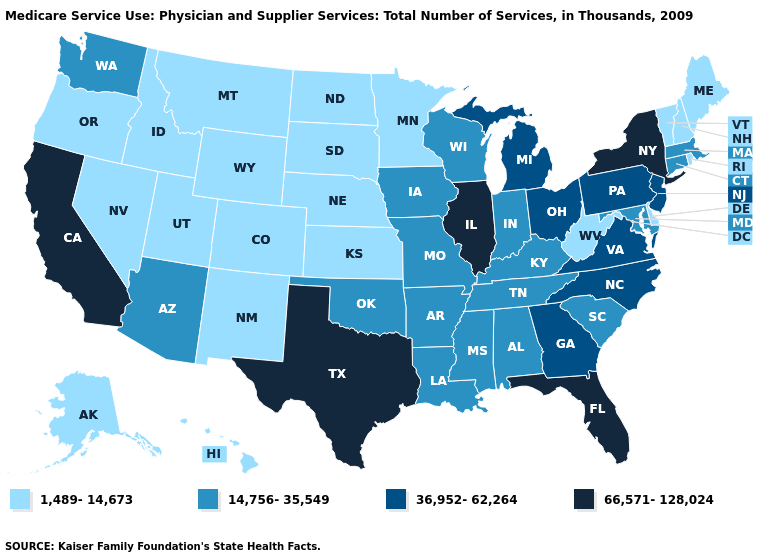Which states have the lowest value in the USA?
Give a very brief answer. Alaska, Colorado, Delaware, Hawaii, Idaho, Kansas, Maine, Minnesota, Montana, Nebraska, Nevada, New Hampshire, New Mexico, North Dakota, Oregon, Rhode Island, South Dakota, Utah, Vermont, West Virginia, Wyoming. What is the value of North Carolina?
Concise answer only. 36,952-62,264. Which states have the lowest value in the USA?
Give a very brief answer. Alaska, Colorado, Delaware, Hawaii, Idaho, Kansas, Maine, Minnesota, Montana, Nebraska, Nevada, New Hampshire, New Mexico, North Dakota, Oregon, Rhode Island, South Dakota, Utah, Vermont, West Virginia, Wyoming. How many symbols are there in the legend?
Be succinct. 4. Name the states that have a value in the range 36,952-62,264?
Keep it brief. Georgia, Michigan, New Jersey, North Carolina, Ohio, Pennsylvania, Virginia. What is the highest value in the USA?
Short answer required. 66,571-128,024. Which states hav the highest value in the MidWest?
Concise answer only. Illinois. Name the states that have a value in the range 66,571-128,024?
Short answer required. California, Florida, Illinois, New York, Texas. Which states have the lowest value in the USA?
Give a very brief answer. Alaska, Colorado, Delaware, Hawaii, Idaho, Kansas, Maine, Minnesota, Montana, Nebraska, Nevada, New Hampshire, New Mexico, North Dakota, Oregon, Rhode Island, South Dakota, Utah, Vermont, West Virginia, Wyoming. Does Kentucky have a lower value than Vermont?
Concise answer only. No. What is the highest value in the USA?
Short answer required. 66,571-128,024. Which states have the lowest value in the Northeast?
Give a very brief answer. Maine, New Hampshire, Rhode Island, Vermont. Does Massachusetts have the same value as Washington?
Answer briefly. Yes. Name the states that have a value in the range 36,952-62,264?
Write a very short answer. Georgia, Michigan, New Jersey, North Carolina, Ohio, Pennsylvania, Virginia. What is the value of Oklahoma?
Answer briefly. 14,756-35,549. 